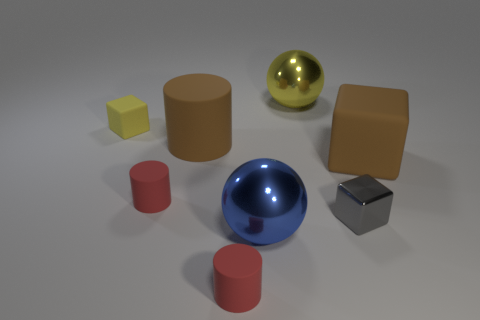Add 2 red things. How many objects exist? 10 Subtract all cylinders. How many objects are left? 5 Add 1 red rubber objects. How many red rubber objects are left? 3 Add 5 large blue metallic balls. How many large blue metallic balls exist? 6 Subtract 1 blue balls. How many objects are left? 7 Subtract all tiny cyan metal cylinders. Subtract all small yellow objects. How many objects are left? 7 